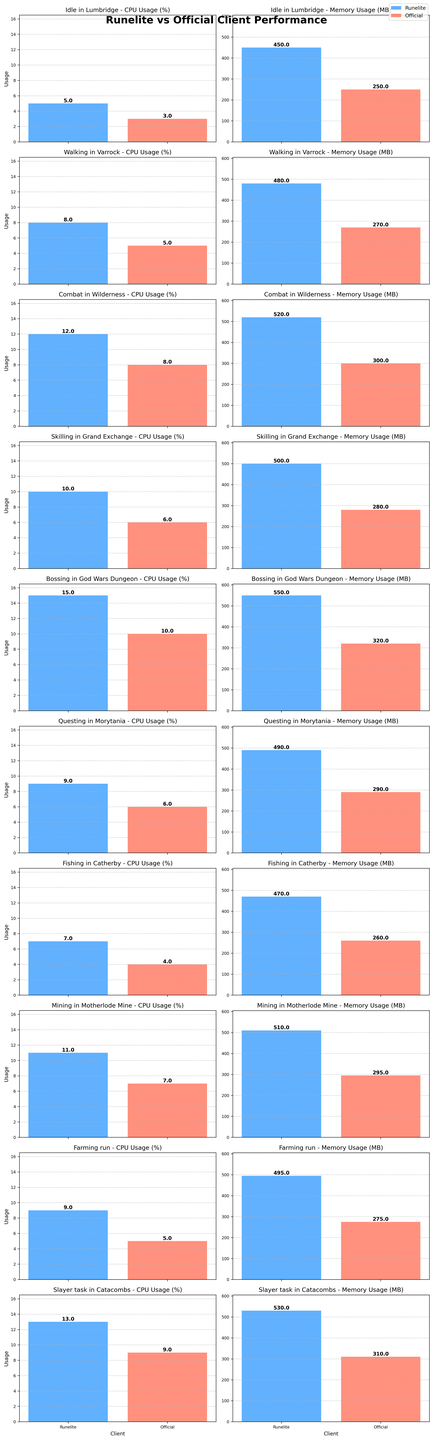Which client has higher CPU usage while idle in Lumbridge? By examining the height of the bars in the Idle in Lumbridge - CPU Usage graph, the bar for Runelite is taller than the bar for Official. Hence, Runelite has higher CPU usage.
Answer: Runelite Which activity shows the greatest difference in memory usage between the two clients? To find this, examine the differences in the heights of the memory usage bars for every activity. The greatest difference appears in "Idle in Lumbridge," where the memory usage bar for Runelite is significantly taller than that for Official.
Answer: Idle in Lumbridge Is CPU usage generally higher for Runelite or the Official client across all activities? Looking at the heights of the CPU Usage bars across all activities, Runelite generally has taller bars (higher CPU usage) for each activity compared to the Official client.
Answer: Runelite What's the average CPU usage for Runelite across all activities? To find the average, sum the CPU usages for Runelite across all listed activities and divide by the number of activities: (5 + 8 + 12 + 10 + 15 + 9 + 7 + 11 + 9 + 13) / 10 = 99 / 10 = 9.9
Answer: 9.9 Which activity consumes the highest memory for the Official client? By examining the heights of the Memory Usage bars for the Official client across all activities, the tallest bar is for "Bossing in God Wars Dungeon," having the highest memory consumption.
Answer: Bossing in God Wars Dungeon For which activity does the Official client have the lowest CPU usage? By checking the heights of CPU Usage bars for the Official client across various activities, the smallest bar corresponds to "Idle in Lumbridge."
Answer: Idle in Lumbridge How much more memory does Runelite use compared to the Official client when combatting in the Wilderness? Subtract the Official client's memory usage from Runelite's for Combat in Wilderness: 520 - 300 = 220 MB.
Answer: 220 MB What's the total memory usage for Runelite across all activities? Sum the memory usage values for Runelite for all activities: 450 + 480 + 520 + 500 + 550 + 490 + 470 + 510 + 495 + 530 = 4995 MB.
Answer: 4995 MB For which activity is the difference in CPU usage between the two clients the smallest? Compare the CPU usage difference for each activity by subtracting the values. The smallest difference is for "Questing in Morytania," where Runelite uses 9% and the Official client uses 6%, a difference of 3%.
Answer: Questing in Morytania 